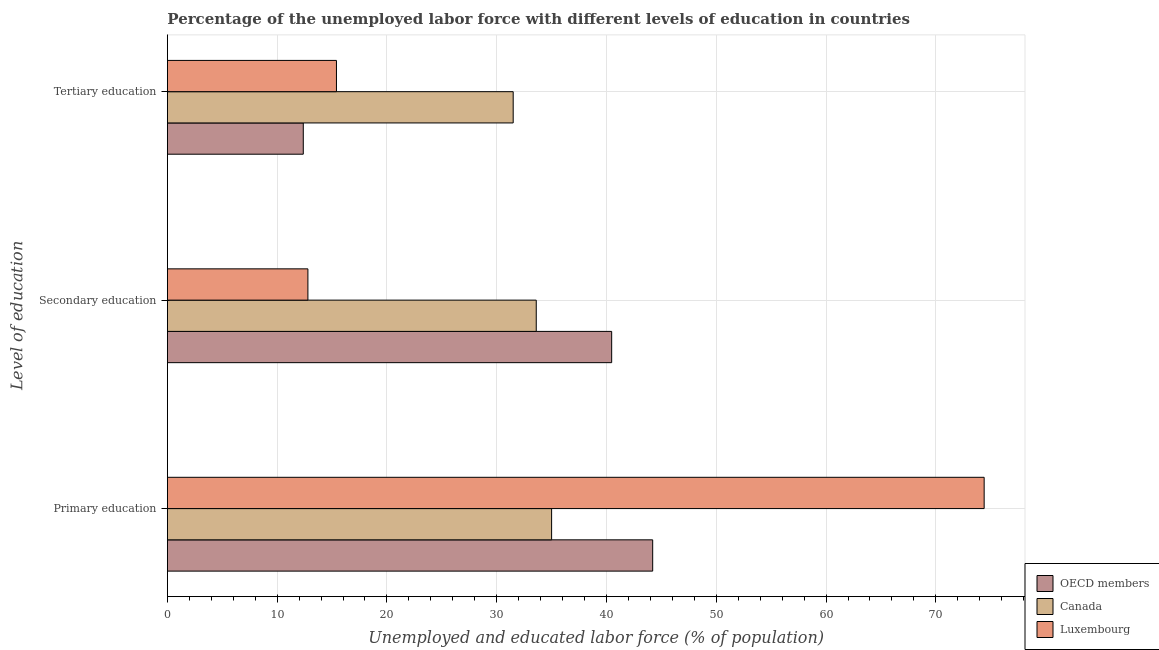How many different coloured bars are there?
Keep it short and to the point. 3. How many groups of bars are there?
Provide a succinct answer. 3. Are the number of bars on each tick of the Y-axis equal?
Give a very brief answer. Yes. How many bars are there on the 3rd tick from the bottom?
Your answer should be very brief. 3. What is the label of the 1st group of bars from the top?
Make the answer very short. Tertiary education. What is the percentage of labor force who received primary education in Luxembourg?
Your answer should be compact. 74.4. Across all countries, what is the maximum percentage of labor force who received secondary education?
Offer a very short reply. 40.47. Across all countries, what is the minimum percentage of labor force who received secondary education?
Give a very brief answer. 12.8. What is the total percentage of labor force who received secondary education in the graph?
Provide a succinct answer. 86.87. What is the difference between the percentage of labor force who received primary education in OECD members and that in Canada?
Provide a short and direct response. 9.21. What is the difference between the percentage of labor force who received tertiary education in OECD members and the percentage of labor force who received primary education in Canada?
Make the answer very short. -22.62. What is the average percentage of labor force who received primary education per country?
Provide a succinct answer. 51.2. What is the difference between the percentage of labor force who received primary education and percentage of labor force who received secondary education in Canada?
Your response must be concise. 1.4. What is the ratio of the percentage of labor force who received secondary education in OECD members to that in Luxembourg?
Give a very brief answer. 3.16. Is the difference between the percentage of labor force who received tertiary education in OECD members and Canada greater than the difference between the percentage of labor force who received primary education in OECD members and Canada?
Your answer should be very brief. No. What is the difference between the highest and the second highest percentage of labor force who received primary education?
Your response must be concise. 30.19. What is the difference between the highest and the lowest percentage of labor force who received tertiary education?
Keep it short and to the point. 19.12. In how many countries, is the percentage of labor force who received secondary education greater than the average percentage of labor force who received secondary education taken over all countries?
Offer a very short reply. 2. Is the sum of the percentage of labor force who received tertiary education in OECD members and Canada greater than the maximum percentage of labor force who received primary education across all countries?
Make the answer very short. No. What does the 2nd bar from the bottom in Primary education represents?
Your answer should be compact. Canada. How many bars are there?
Provide a short and direct response. 9. Are all the bars in the graph horizontal?
Offer a very short reply. Yes. How many countries are there in the graph?
Provide a succinct answer. 3. Does the graph contain any zero values?
Your answer should be very brief. No. Does the graph contain grids?
Your answer should be compact. Yes. How are the legend labels stacked?
Your answer should be very brief. Vertical. What is the title of the graph?
Keep it short and to the point. Percentage of the unemployed labor force with different levels of education in countries. What is the label or title of the X-axis?
Provide a succinct answer. Unemployed and educated labor force (% of population). What is the label or title of the Y-axis?
Your answer should be compact. Level of education. What is the Unemployed and educated labor force (% of population) of OECD members in Primary education?
Keep it short and to the point. 44.21. What is the Unemployed and educated labor force (% of population) of Canada in Primary education?
Your answer should be very brief. 35. What is the Unemployed and educated labor force (% of population) in Luxembourg in Primary education?
Your response must be concise. 74.4. What is the Unemployed and educated labor force (% of population) in OECD members in Secondary education?
Offer a terse response. 40.47. What is the Unemployed and educated labor force (% of population) in Canada in Secondary education?
Offer a very short reply. 33.6. What is the Unemployed and educated labor force (% of population) of Luxembourg in Secondary education?
Provide a succinct answer. 12.8. What is the Unemployed and educated labor force (% of population) of OECD members in Tertiary education?
Provide a succinct answer. 12.38. What is the Unemployed and educated labor force (% of population) of Canada in Tertiary education?
Ensure brevity in your answer.  31.5. What is the Unemployed and educated labor force (% of population) in Luxembourg in Tertiary education?
Give a very brief answer. 15.4. Across all Level of education, what is the maximum Unemployed and educated labor force (% of population) in OECD members?
Offer a terse response. 44.21. Across all Level of education, what is the maximum Unemployed and educated labor force (% of population) of Canada?
Give a very brief answer. 35. Across all Level of education, what is the maximum Unemployed and educated labor force (% of population) of Luxembourg?
Make the answer very short. 74.4. Across all Level of education, what is the minimum Unemployed and educated labor force (% of population) of OECD members?
Your answer should be compact. 12.38. Across all Level of education, what is the minimum Unemployed and educated labor force (% of population) of Canada?
Ensure brevity in your answer.  31.5. Across all Level of education, what is the minimum Unemployed and educated labor force (% of population) in Luxembourg?
Your response must be concise. 12.8. What is the total Unemployed and educated labor force (% of population) of OECD members in the graph?
Your answer should be very brief. 97.06. What is the total Unemployed and educated labor force (% of population) in Canada in the graph?
Your answer should be very brief. 100.1. What is the total Unemployed and educated labor force (% of population) in Luxembourg in the graph?
Give a very brief answer. 102.6. What is the difference between the Unemployed and educated labor force (% of population) in OECD members in Primary education and that in Secondary education?
Offer a terse response. 3.74. What is the difference between the Unemployed and educated labor force (% of population) in Luxembourg in Primary education and that in Secondary education?
Make the answer very short. 61.6. What is the difference between the Unemployed and educated labor force (% of population) in OECD members in Primary education and that in Tertiary education?
Ensure brevity in your answer.  31.83. What is the difference between the Unemployed and educated labor force (% of population) of Luxembourg in Primary education and that in Tertiary education?
Give a very brief answer. 59. What is the difference between the Unemployed and educated labor force (% of population) in OECD members in Secondary education and that in Tertiary education?
Your response must be concise. 28.09. What is the difference between the Unemployed and educated labor force (% of population) in OECD members in Primary education and the Unemployed and educated labor force (% of population) in Canada in Secondary education?
Offer a very short reply. 10.61. What is the difference between the Unemployed and educated labor force (% of population) in OECD members in Primary education and the Unemployed and educated labor force (% of population) in Luxembourg in Secondary education?
Keep it short and to the point. 31.41. What is the difference between the Unemployed and educated labor force (% of population) of OECD members in Primary education and the Unemployed and educated labor force (% of population) of Canada in Tertiary education?
Keep it short and to the point. 12.71. What is the difference between the Unemployed and educated labor force (% of population) of OECD members in Primary education and the Unemployed and educated labor force (% of population) of Luxembourg in Tertiary education?
Offer a terse response. 28.81. What is the difference between the Unemployed and educated labor force (% of population) in Canada in Primary education and the Unemployed and educated labor force (% of population) in Luxembourg in Tertiary education?
Provide a succinct answer. 19.6. What is the difference between the Unemployed and educated labor force (% of population) of OECD members in Secondary education and the Unemployed and educated labor force (% of population) of Canada in Tertiary education?
Offer a terse response. 8.97. What is the difference between the Unemployed and educated labor force (% of population) in OECD members in Secondary education and the Unemployed and educated labor force (% of population) in Luxembourg in Tertiary education?
Keep it short and to the point. 25.07. What is the average Unemployed and educated labor force (% of population) in OECD members per Level of education?
Give a very brief answer. 32.35. What is the average Unemployed and educated labor force (% of population) of Canada per Level of education?
Your answer should be very brief. 33.37. What is the average Unemployed and educated labor force (% of population) in Luxembourg per Level of education?
Your answer should be very brief. 34.2. What is the difference between the Unemployed and educated labor force (% of population) in OECD members and Unemployed and educated labor force (% of population) in Canada in Primary education?
Your response must be concise. 9.21. What is the difference between the Unemployed and educated labor force (% of population) in OECD members and Unemployed and educated labor force (% of population) in Luxembourg in Primary education?
Ensure brevity in your answer.  -30.19. What is the difference between the Unemployed and educated labor force (% of population) of Canada and Unemployed and educated labor force (% of population) of Luxembourg in Primary education?
Provide a short and direct response. -39.4. What is the difference between the Unemployed and educated labor force (% of population) in OECD members and Unemployed and educated labor force (% of population) in Canada in Secondary education?
Make the answer very short. 6.87. What is the difference between the Unemployed and educated labor force (% of population) in OECD members and Unemployed and educated labor force (% of population) in Luxembourg in Secondary education?
Provide a short and direct response. 27.67. What is the difference between the Unemployed and educated labor force (% of population) of Canada and Unemployed and educated labor force (% of population) of Luxembourg in Secondary education?
Your answer should be very brief. 20.8. What is the difference between the Unemployed and educated labor force (% of population) in OECD members and Unemployed and educated labor force (% of population) in Canada in Tertiary education?
Give a very brief answer. -19.12. What is the difference between the Unemployed and educated labor force (% of population) of OECD members and Unemployed and educated labor force (% of population) of Luxembourg in Tertiary education?
Offer a terse response. -3.02. What is the ratio of the Unemployed and educated labor force (% of population) in OECD members in Primary education to that in Secondary education?
Offer a terse response. 1.09. What is the ratio of the Unemployed and educated labor force (% of population) of Canada in Primary education to that in Secondary education?
Your response must be concise. 1.04. What is the ratio of the Unemployed and educated labor force (% of population) in Luxembourg in Primary education to that in Secondary education?
Ensure brevity in your answer.  5.81. What is the ratio of the Unemployed and educated labor force (% of population) of OECD members in Primary education to that in Tertiary education?
Make the answer very short. 3.57. What is the ratio of the Unemployed and educated labor force (% of population) in Canada in Primary education to that in Tertiary education?
Ensure brevity in your answer.  1.11. What is the ratio of the Unemployed and educated labor force (% of population) of Luxembourg in Primary education to that in Tertiary education?
Give a very brief answer. 4.83. What is the ratio of the Unemployed and educated labor force (% of population) in OECD members in Secondary education to that in Tertiary education?
Your answer should be compact. 3.27. What is the ratio of the Unemployed and educated labor force (% of population) of Canada in Secondary education to that in Tertiary education?
Your response must be concise. 1.07. What is the ratio of the Unemployed and educated labor force (% of population) in Luxembourg in Secondary education to that in Tertiary education?
Your answer should be very brief. 0.83. What is the difference between the highest and the second highest Unemployed and educated labor force (% of population) of OECD members?
Give a very brief answer. 3.74. What is the difference between the highest and the second highest Unemployed and educated labor force (% of population) of Canada?
Give a very brief answer. 1.4. What is the difference between the highest and the second highest Unemployed and educated labor force (% of population) in Luxembourg?
Your answer should be compact. 59. What is the difference between the highest and the lowest Unemployed and educated labor force (% of population) of OECD members?
Keep it short and to the point. 31.83. What is the difference between the highest and the lowest Unemployed and educated labor force (% of population) of Canada?
Provide a short and direct response. 3.5. What is the difference between the highest and the lowest Unemployed and educated labor force (% of population) of Luxembourg?
Your response must be concise. 61.6. 